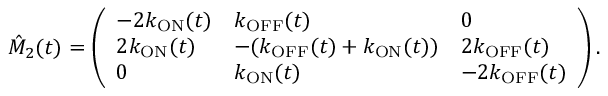<formula> <loc_0><loc_0><loc_500><loc_500>\hat { M } _ { 2 } ( t ) = \left ( \begin{array} { l l l } { - 2 k _ { O N } ( t ) } & { k _ { O F F } ( t ) } & { 0 } \\ { 2 k _ { O N } ( t ) } & { - ( k _ { O F F } ( t ) + k _ { O N } ( t ) ) } & { 2 k _ { O F F } ( t ) } \\ { 0 } & { k _ { O N } ( t ) } & { - 2 k _ { O F F } ( t ) } \end{array} \right ) .</formula> 